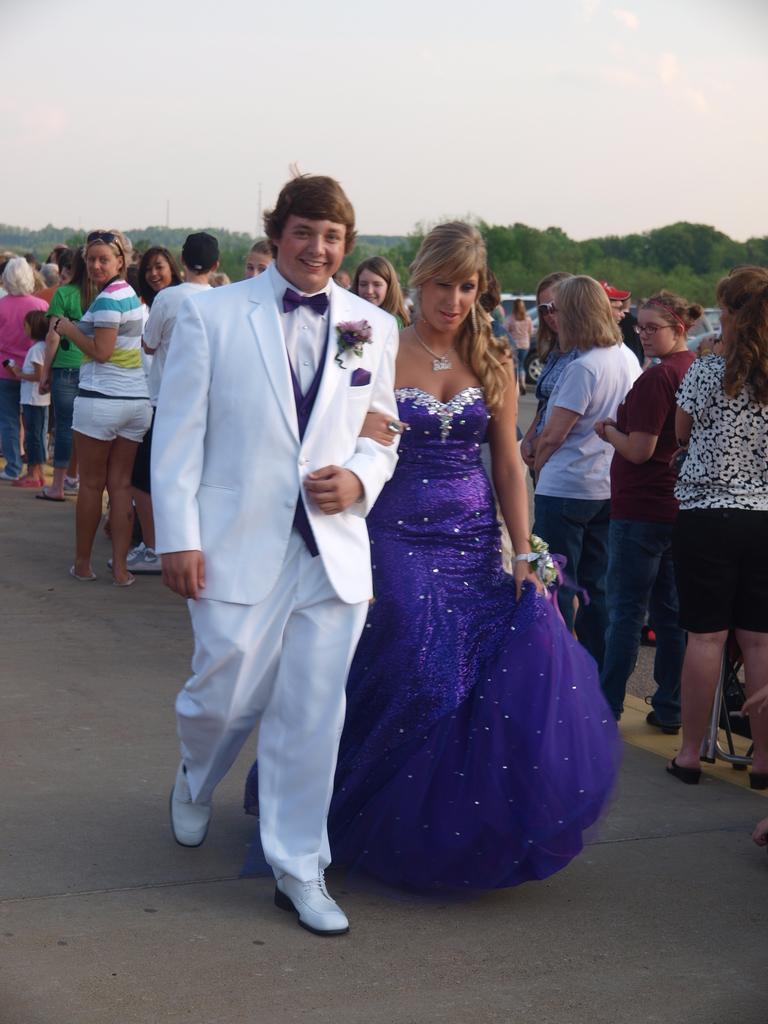In one or two sentences, can you explain what this image depicts? In this image there are a couple walking at the road, behind them there are so many people standing on the road also there are mountains covered with trees at the back. 